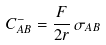<formula> <loc_0><loc_0><loc_500><loc_500>C ^ { - } _ { A B } = \frac { F } { 2 r } \, \sigma _ { A B }</formula> 